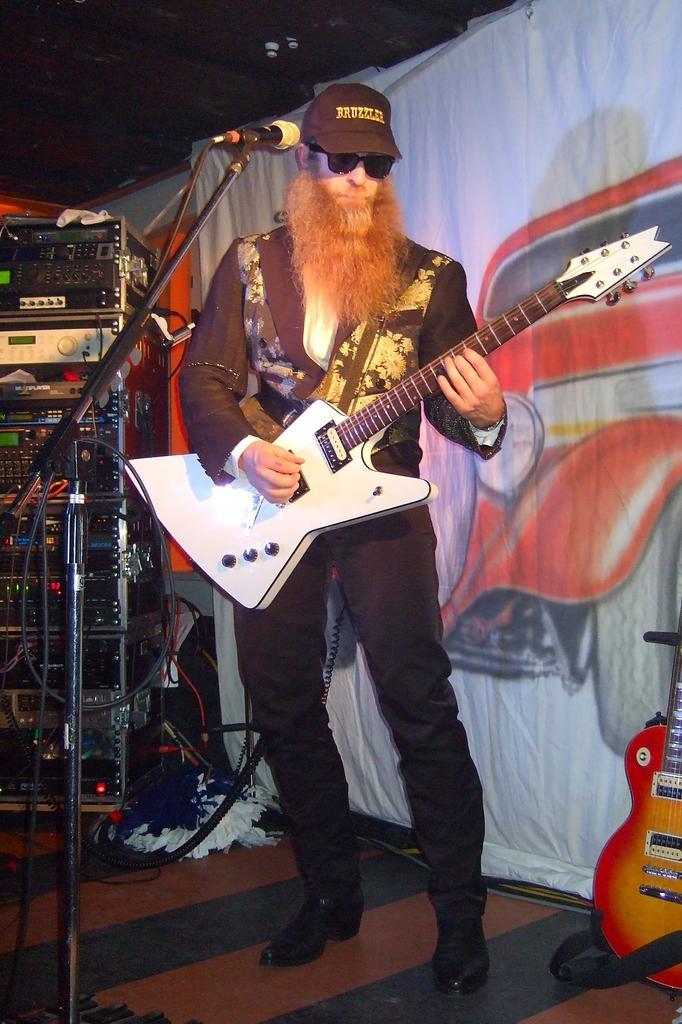How would you summarize this image in a sentence or two? In this image, we can see a man playing guitar and in the background, we can see musical instruments and there is a banner. On the bottom right, there is a guitar. 